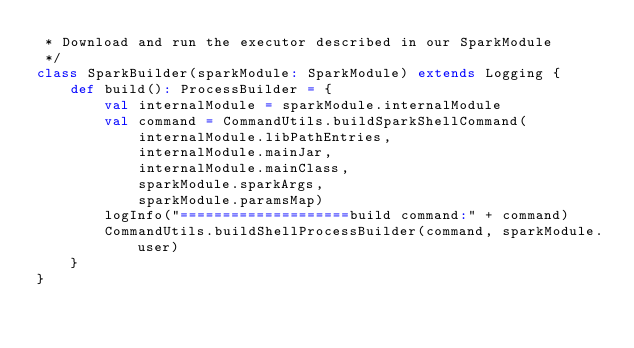Convert code to text. <code><loc_0><loc_0><loc_500><loc_500><_Scala_> * Download and run the executor described in our SparkModule
 */
class SparkBuilder(sparkModule: SparkModule) extends Logging {
    def build(): ProcessBuilder = {
        val internalModule = sparkModule.internalModule
        val command = CommandUtils.buildSparkShellCommand(
            internalModule.libPathEntries,
            internalModule.mainJar,
            internalModule.mainClass,
            sparkModule.sparkArgs,
            sparkModule.paramsMap)
        logInfo("====================build command:" + command)
        CommandUtils.buildShellProcessBuilder(command, sparkModule.user)
    }
}
</code> 